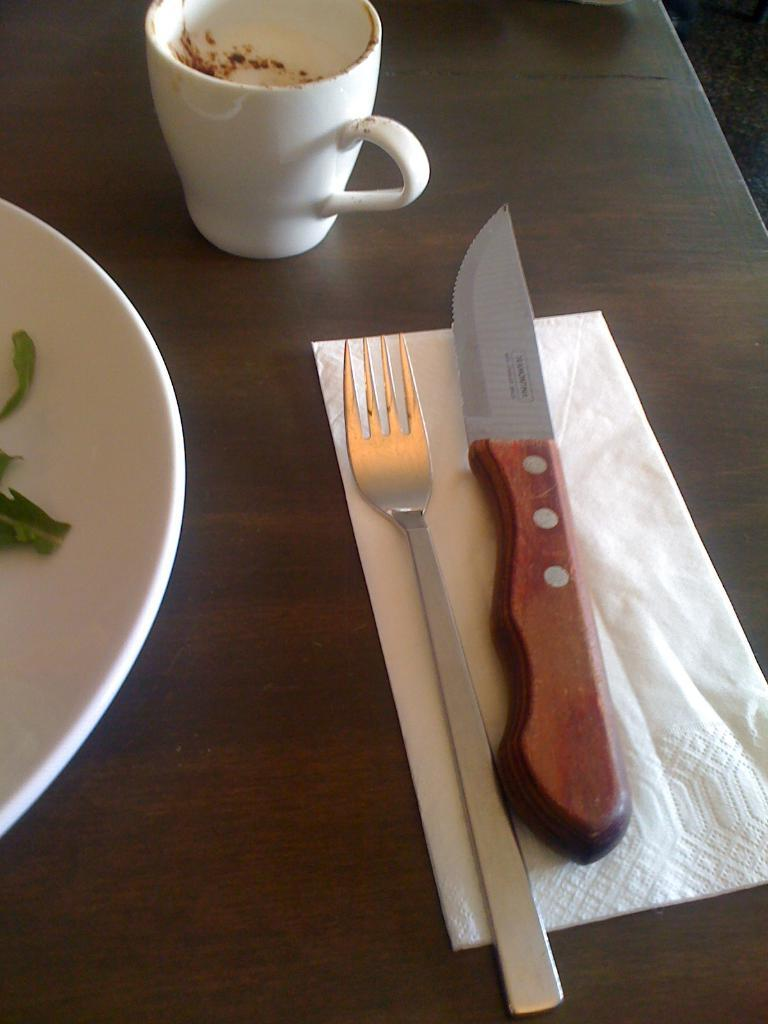What piece of furniture is present in the image? There is a table in the image. What is placed on the table? There is a plate, a cup, a knife, a fork, and tissue paper on the table. How many utensils are on the table? There is a knife and a fork on the table. What type of stitch is being used to hold the middle of the table together? There is no mention of a stitch or any need for it in the image, as the table appears to be a solid piece of furniture. 